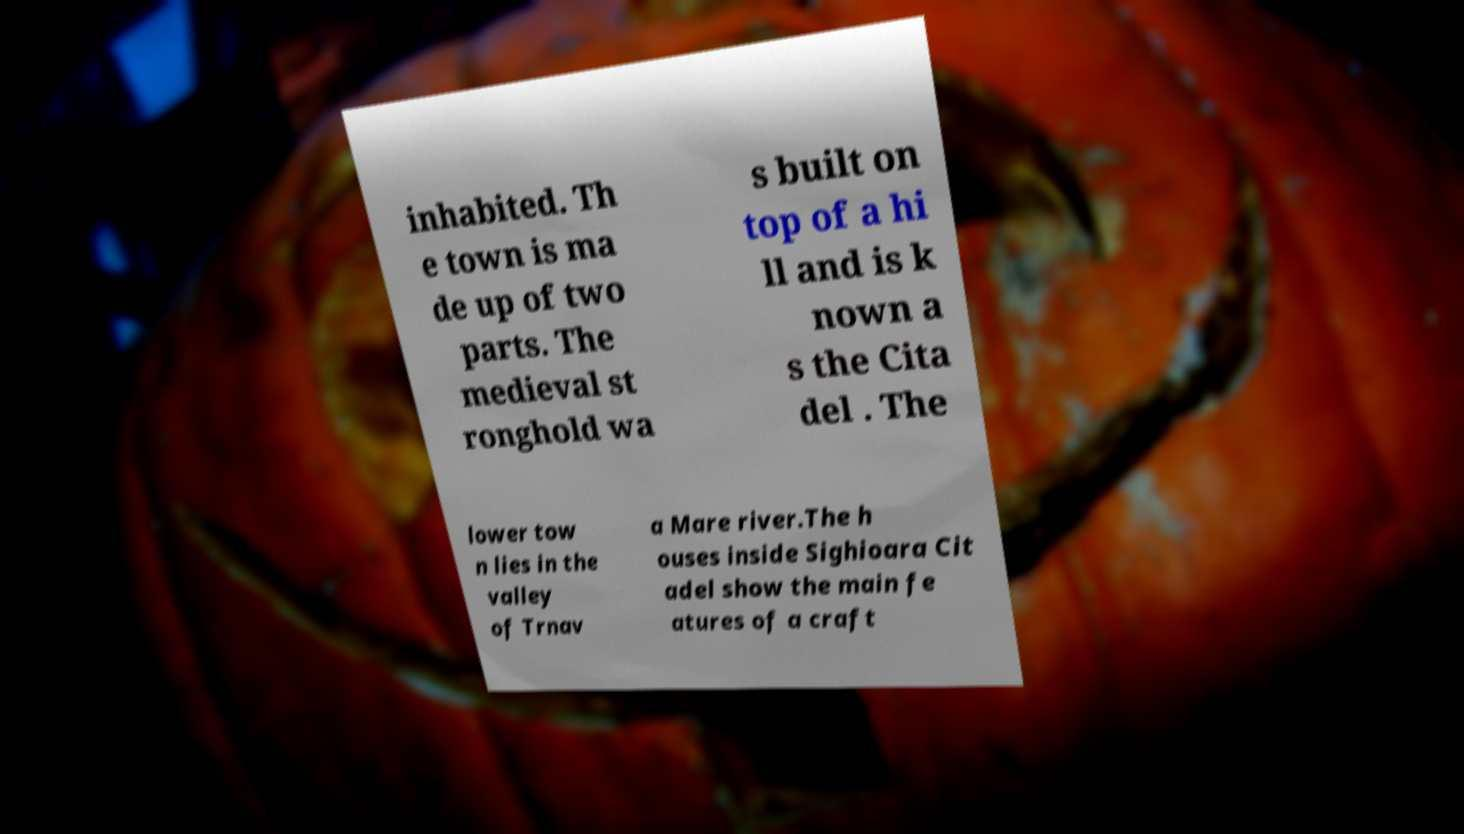For documentation purposes, I need the text within this image transcribed. Could you provide that? inhabited. Th e town is ma de up of two parts. The medieval st ronghold wa s built on top of a hi ll and is k nown a s the Cita del . The lower tow n lies in the valley of Trnav a Mare river.The h ouses inside Sighioara Cit adel show the main fe atures of a craft 